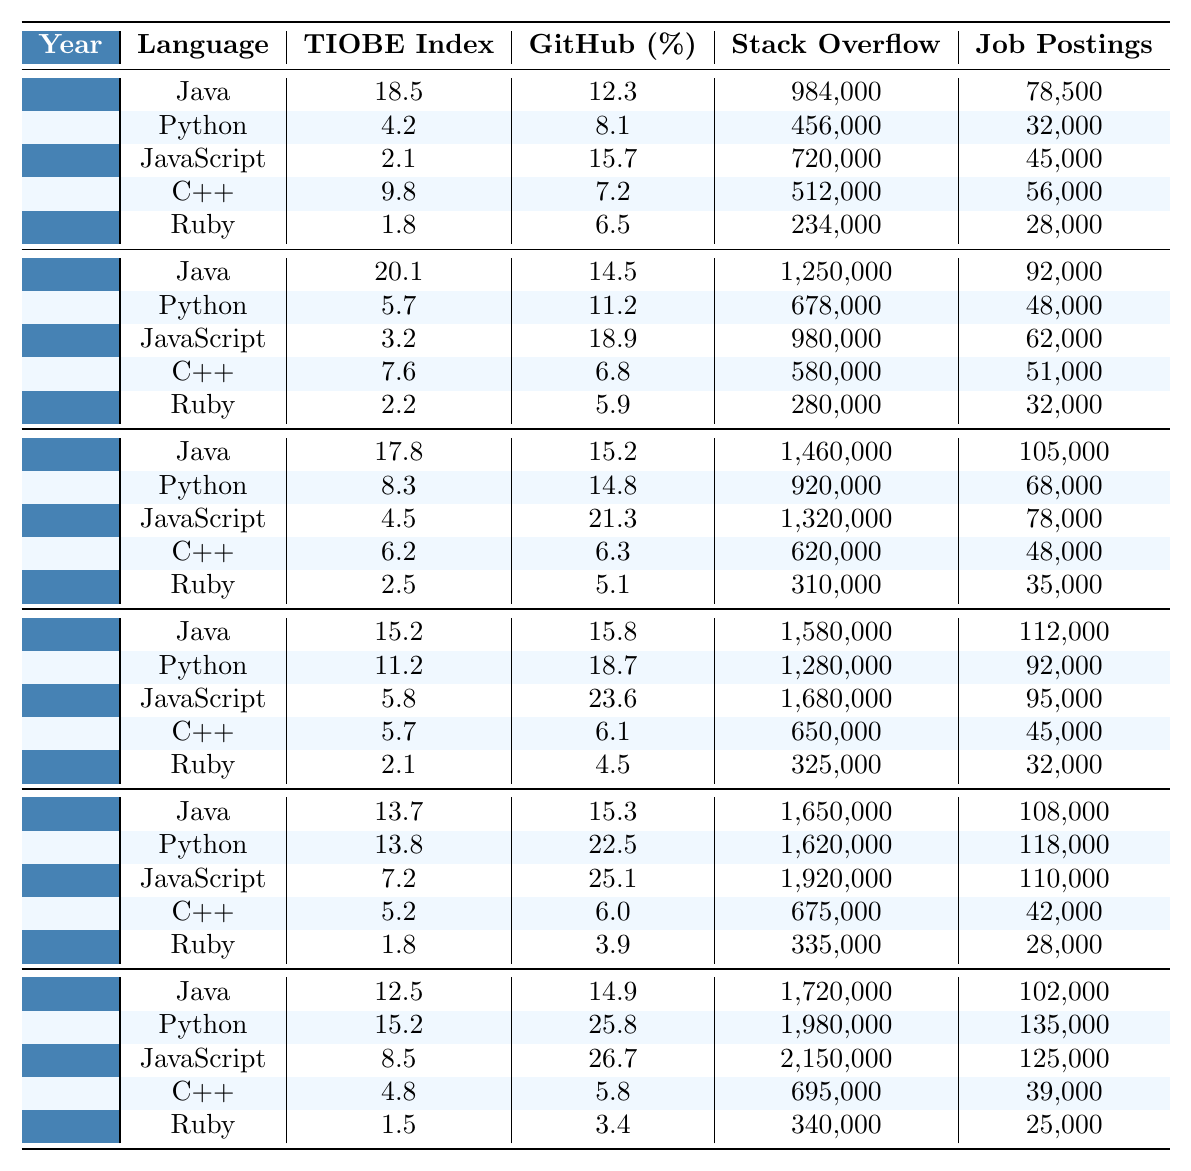What was the TIOBE Index score for Python in 2021? Referring to the row for the year 2021, Python has a TIOBE Index score of 13.8.
Answer: 13.8 Which programming language had the highest job postings in 2019? In 2019, Java had the highest job postings at 112,000, compared to other languages listed.
Answer: Java What is the average TIOBE Index score for Java over the years presented? The TIOBE Index scores for Java are 18.5, 20.1, 17.8, 15.2, 13.7, and 12.5. Summing these scores results in 97.8, and dividing by 6 gives an average of 16.3.
Answer: 16.3 Did the percentage of GitHub repositories for JavaScript increase from 2013 to 2023? In 2013, JavaScript had 15.7% of GitHub repositories. In 2023, this increased to 26.7%. Therefore, the percentage increased.
Answer: Yes What language consistently had the highest percentage of GitHub repositories across the years? By checking each row, we see that JavaScript consistently had the highest GitHub percentage in all the years provided.
Answer: JavaScript How many more Stack Overflow questions were asked for Python than for Ruby in 2017? In 2017, Python had 92,000 Stack Overflow questions, whereas Ruby had 35,000. The difference is 92,000 - 35,000 = 57,000.
Answer: 57,000 In 2021, what percentage increase in job postings for Python occurred compared to 2015? In 2021, Python had 118,000 job postings compared to 48,000 in 2015. The percentage increase is ((118,000 - 48,000) / 48,000) * 100 = 145.83%.
Answer: 145.83% Which language saw the largest increase in Stack Overflow questions from 2013 to 2023? Comparing the Stack Overflow questions: Python increased from 32,000 in 2013 to 135,000 in 2023 (103,000 increase), while JavaScript increased from 45,000 to 125,000 (80,000 increase). Python had the largest increase.
Answer: Python What was the TIOBE Index score for C++ in the year with the highest recorded score? Checking each year, the highest TIOBE Index score for C++ was 9.8 in 2013, compared to lower scores in other years.
Answer: 9.8 Did the trend show an overall increase in TIOBE Index score for Python from 2013 to 2023? Python's TIOBE Index scores went from 4.2 in 2013 to 15.2 in 2023, indicating an overall increase in popularity.
Answer: Yes 